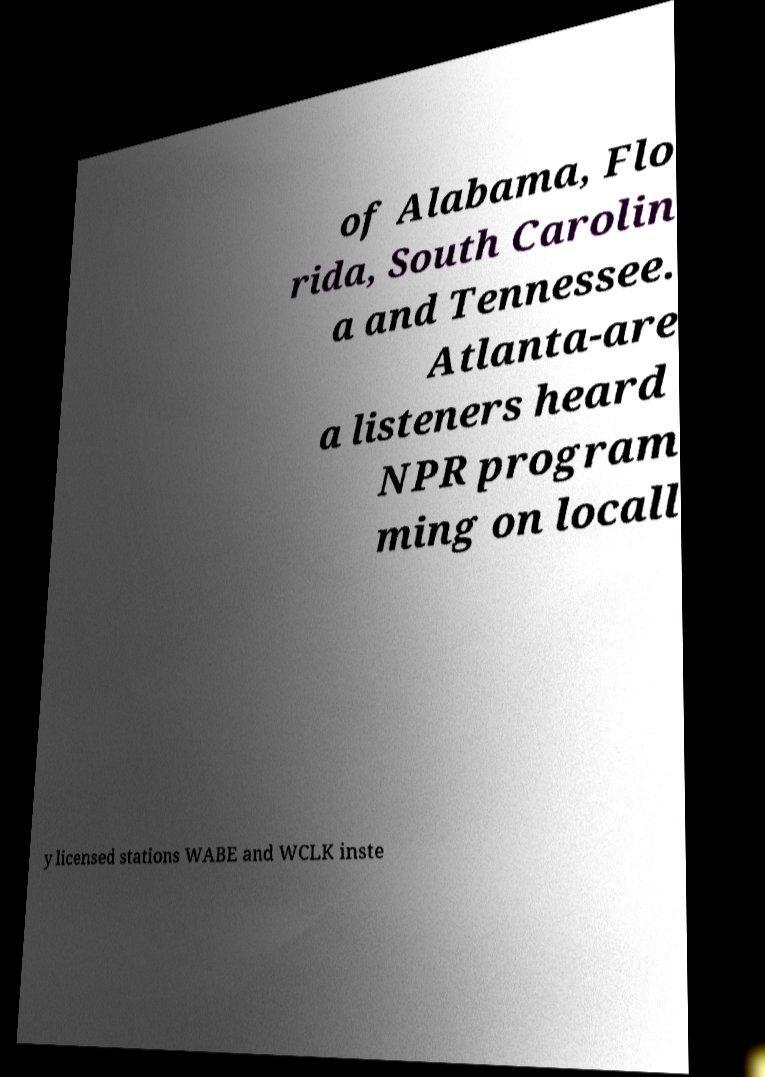I need the written content from this picture converted into text. Can you do that? of Alabama, Flo rida, South Carolin a and Tennessee. Atlanta-are a listeners heard NPR program ming on locall y licensed stations WABE and WCLK inste 